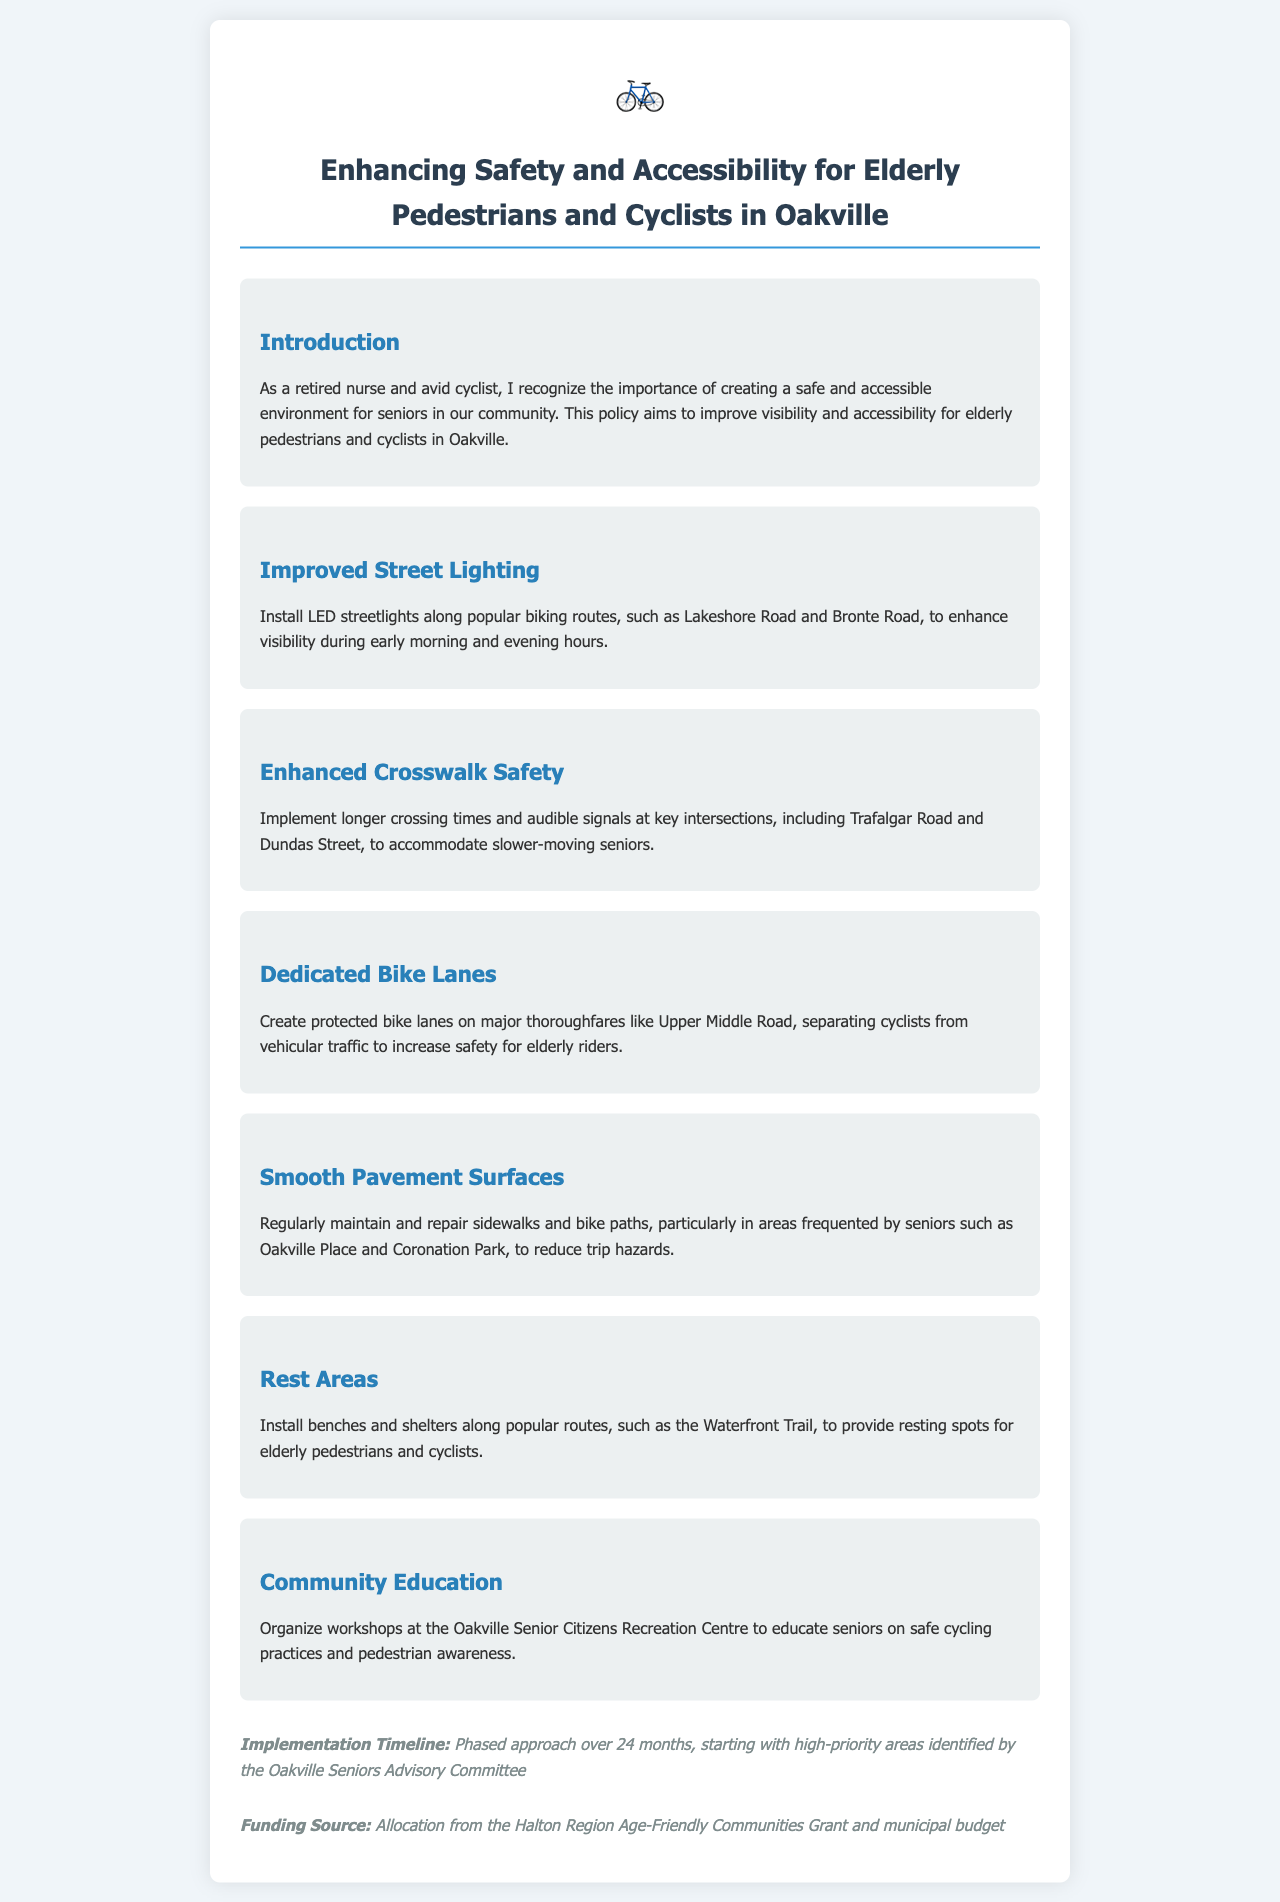What is the title of the policy document? The title of the policy document is stated at the beginning, which outlines the purpose to enhance safety and accessibility for seniors.
Answer: Enhancing Safety and Accessibility for Elderly Pedestrians and Cyclists in Oakville How long is the implementation timeline? The implementation timeline is specifically mentioned in the document, detailing the planned duration for the initiative.
Answer: 24 months Which major road will have dedicated bike lanes? The document specifies the major thoroughfare where protected bike lanes will be created to improve safety for cyclists.
Answer: Upper Middle Road What is one of the funding sources for this initiative? The document lists funding sources intended to support the safety initiative, one of which is named explicitly.
Answer: Halton Region Age-Friendly Communities Grant What specific community location will host workshops for seniors? The document indicates where educational workshops will be organized for senior citizens regarding safety practices.
Answer: Oakville Senior Citizens Recreation Centre Why are longer crossing times being implemented? The reasoning for longer crossing times is clarified in the context of the needs of the demographic targeted by this policy.
Answer: To accommodate slower-moving seniors What kind of lighting is proposed for improved visibility? The document discusses improvements in street lighting to enhance pedestrian and cyclist safety during certain hours.
Answer: LED streetlights What is one of the popular biking routes mentioned? The document notes popular routes for biking that will undergo safety improvements as part of the initiative.
Answer: Lakeshore Road 